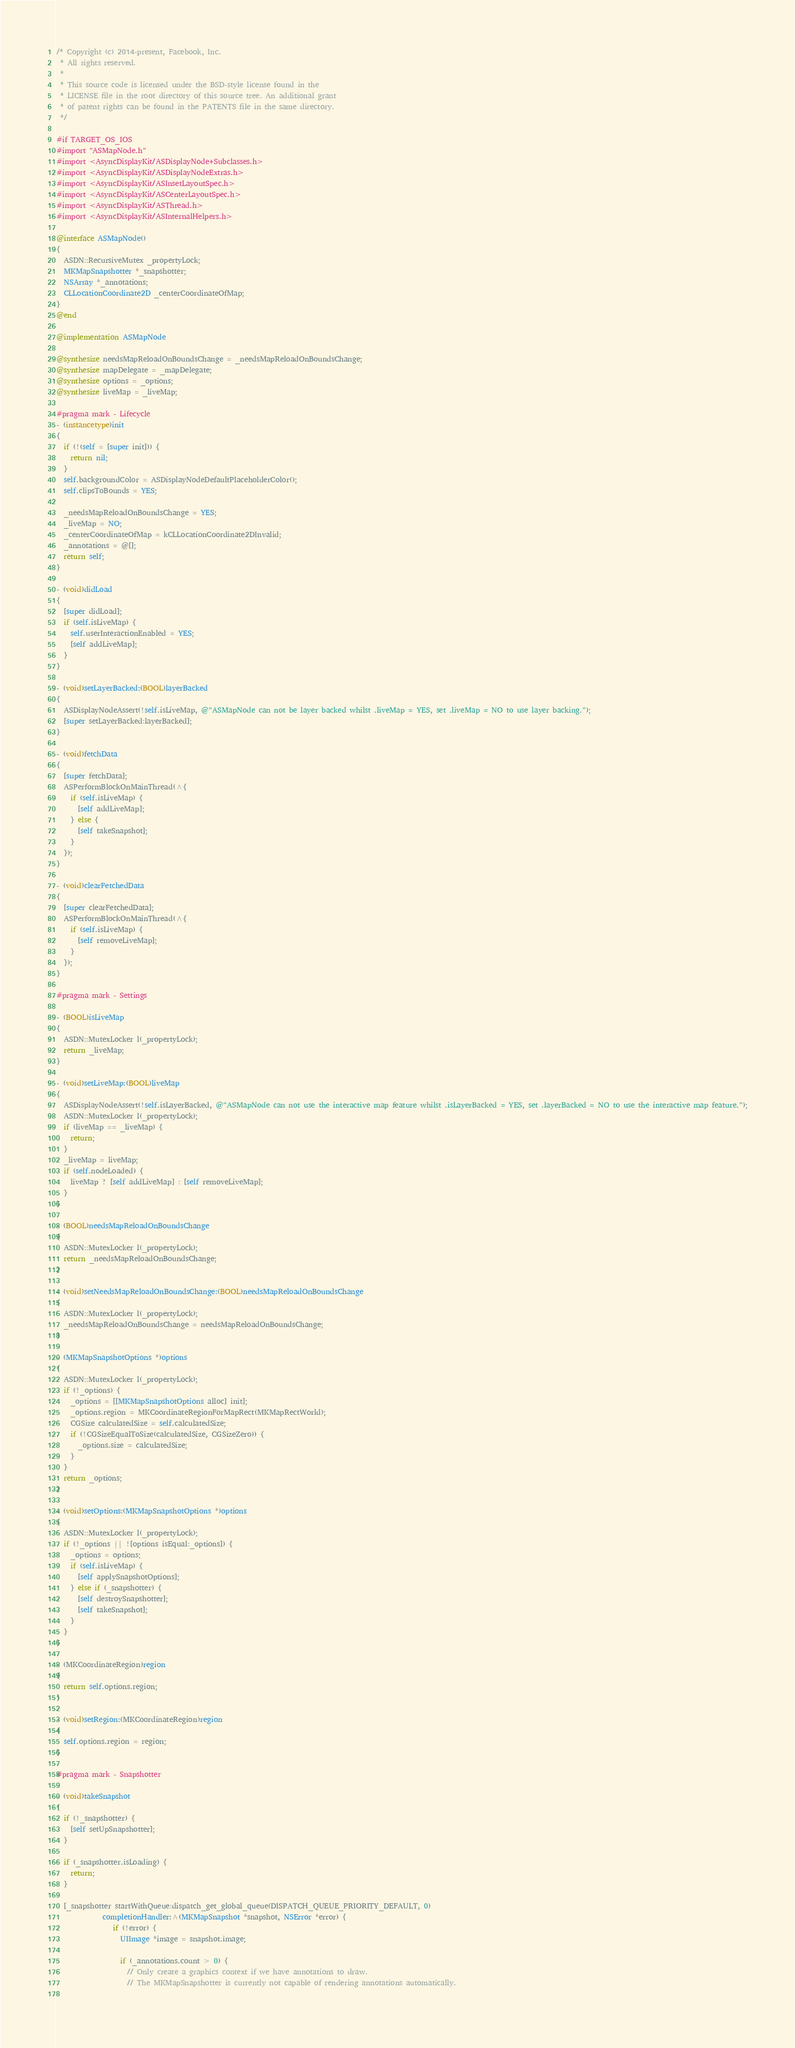Convert code to text. <code><loc_0><loc_0><loc_500><loc_500><_ObjectiveC_>/* Copyright (c) 2014-present, Facebook, Inc.
 * All rights reserved.
 *
 * This source code is licensed under the BSD-style license found in the
 * LICENSE file in the root directory of this source tree. An additional grant
 * of patent rights can be found in the PATENTS file in the same directory.
 */

#if TARGET_OS_IOS
#import "ASMapNode.h"
#import <AsyncDisplayKit/ASDisplayNode+Subclasses.h>
#import <AsyncDisplayKit/ASDisplayNodeExtras.h>
#import <AsyncDisplayKit/ASInsetLayoutSpec.h>
#import <AsyncDisplayKit/ASCenterLayoutSpec.h>
#import <AsyncDisplayKit/ASThread.h>
#import <AsyncDisplayKit/ASInternalHelpers.h>

@interface ASMapNode()
{
  ASDN::RecursiveMutex _propertyLock;
  MKMapSnapshotter *_snapshotter;
  NSArray *_annotations;
  CLLocationCoordinate2D _centerCoordinateOfMap;
}
@end

@implementation ASMapNode

@synthesize needsMapReloadOnBoundsChange = _needsMapReloadOnBoundsChange;
@synthesize mapDelegate = _mapDelegate;
@synthesize options = _options;
@synthesize liveMap = _liveMap;

#pragma mark - Lifecycle
- (instancetype)init
{
  if (!(self = [super init])) {
    return nil;
  }
  self.backgroundColor = ASDisplayNodeDefaultPlaceholderColor();
  self.clipsToBounds = YES;
  
  _needsMapReloadOnBoundsChange = YES;
  _liveMap = NO;
  _centerCoordinateOfMap = kCLLocationCoordinate2DInvalid;
  _annotations = @[];
  return self;
}

- (void)didLoad
{
  [super didLoad];
  if (self.isLiveMap) {
    self.userInteractionEnabled = YES;
    [self addLiveMap];
  }
}

- (void)setLayerBacked:(BOOL)layerBacked
{
  ASDisplayNodeAssert(!self.isLiveMap, @"ASMapNode can not be layer backed whilst .liveMap = YES, set .liveMap = NO to use layer backing.");
  [super setLayerBacked:layerBacked];
}

- (void)fetchData
{
  [super fetchData];
  ASPerformBlockOnMainThread(^{
    if (self.isLiveMap) {
      [self addLiveMap];
    } else {
      [self takeSnapshot];
    }
  });
}

- (void)clearFetchedData
{
  [super clearFetchedData];
  ASPerformBlockOnMainThread(^{
    if (self.isLiveMap) {
      [self removeLiveMap];
    }
  });
}

#pragma mark - Settings

- (BOOL)isLiveMap
{
  ASDN::MutexLocker l(_propertyLock);
  return _liveMap;
}

- (void)setLiveMap:(BOOL)liveMap
{
  ASDisplayNodeAssert(!self.isLayerBacked, @"ASMapNode can not use the interactive map feature whilst .isLayerBacked = YES, set .layerBacked = NO to use the interactive map feature.");
  ASDN::MutexLocker l(_propertyLock);
  if (liveMap == _liveMap) {
    return;
  }
  _liveMap = liveMap;
  if (self.nodeLoaded) {
    liveMap ? [self addLiveMap] : [self removeLiveMap];
  }
}

- (BOOL)needsMapReloadOnBoundsChange
{
  ASDN::MutexLocker l(_propertyLock);
  return _needsMapReloadOnBoundsChange;
}

- (void)setNeedsMapReloadOnBoundsChange:(BOOL)needsMapReloadOnBoundsChange
{
  ASDN::MutexLocker l(_propertyLock);
  _needsMapReloadOnBoundsChange = needsMapReloadOnBoundsChange;
}

- (MKMapSnapshotOptions *)options
{
  ASDN::MutexLocker l(_propertyLock);
  if (!_options) {
    _options = [[MKMapSnapshotOptions alloc] init];
    _options.region = MKCoordinateRegionForMapRect(MKMapRectWorld);
    CGSize calculatedSize = self.calculatedSize;
    if (!CGSizeEqualToSize(calculatedSize, CGSizeZero)) {
      _options.size = calculatedSize;
    }
  }
  return _options;
}

- (void)setOptions:(MKMapSnapshotOptions *)options
{
  ASDN::MutexLocker l(_propertyLock);
  if (!_options || ![options isEqual:_options]) {
    _options = options;
    if (self.isLiveMap) {
      [self applySnapshotOptions];
    } else if (_snapshotter) {
      [self destroySnapshotter];
      [self takeSnapshot];
    }
  }
}

- (MKCoordinateRegion)region
{
  return self.options.region;
}

- (void)setRegion:(MKCoordinateRegion)region
{
  self.options.region = region;
}

#pragma mark - Snapshotter

- (void)takeSnapshot
{
  if (!_snapshotter) {
    [self setUpSnapshotter];
  }
  
  if (_snapshotter.isLoading) {
    return;
  }

  [_snapshotter startWithQueue:dispatch_get_global_queue(DISPATCH_QUEUE_PRIORITY_DEFAULT, 0)
             completionHandler:^(MKMapSnapshot *snapshot, NSError *error) {
                if (!error) {
                  UIImage *image = snapshot.image;
                  
                  if (_annotations.count > 0) {
                    // Only create a graphics context if we have annotations to draw.
                    // The MKMapSnapshotter is currently not capable of rendering annotations automatically.
                    </code> 